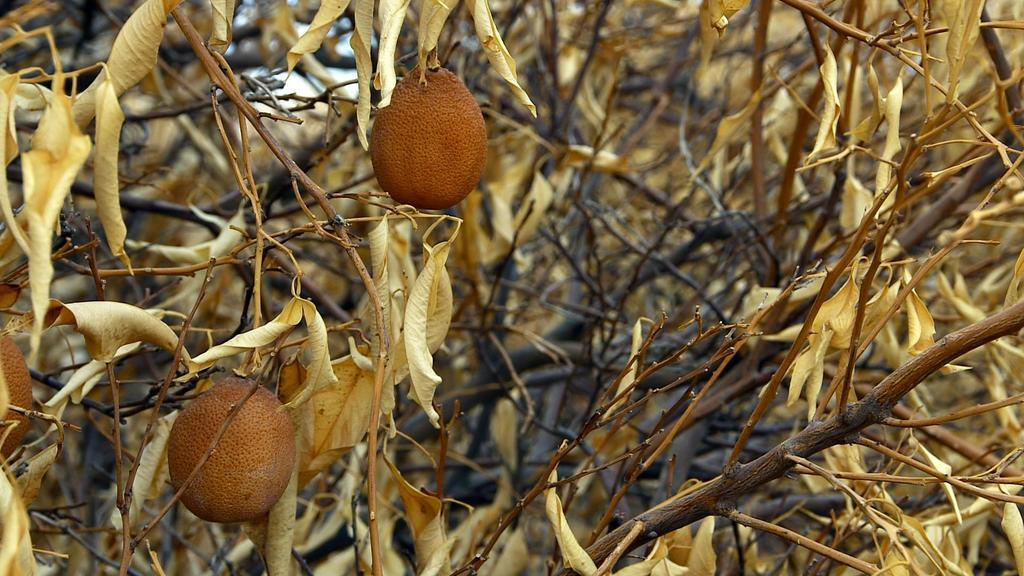What type of living organisms can be seen in the image? Plants can be seen in the image. What is the condition of the leaves on the plants? The leaves on the plants have dried. What else can be observed on the plants? The plants have fruits. What color is the pen used to draw on the rat in the image? There is no pen or rat present in the image; it features plants with dried leaves and fruits. 